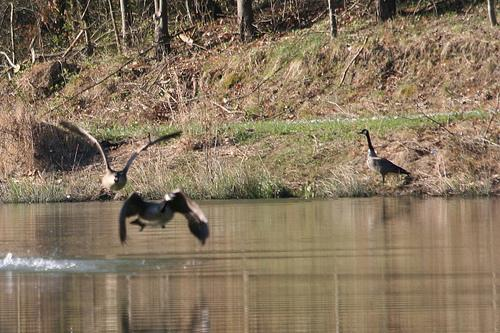These animals have an impressive what? wingspan 